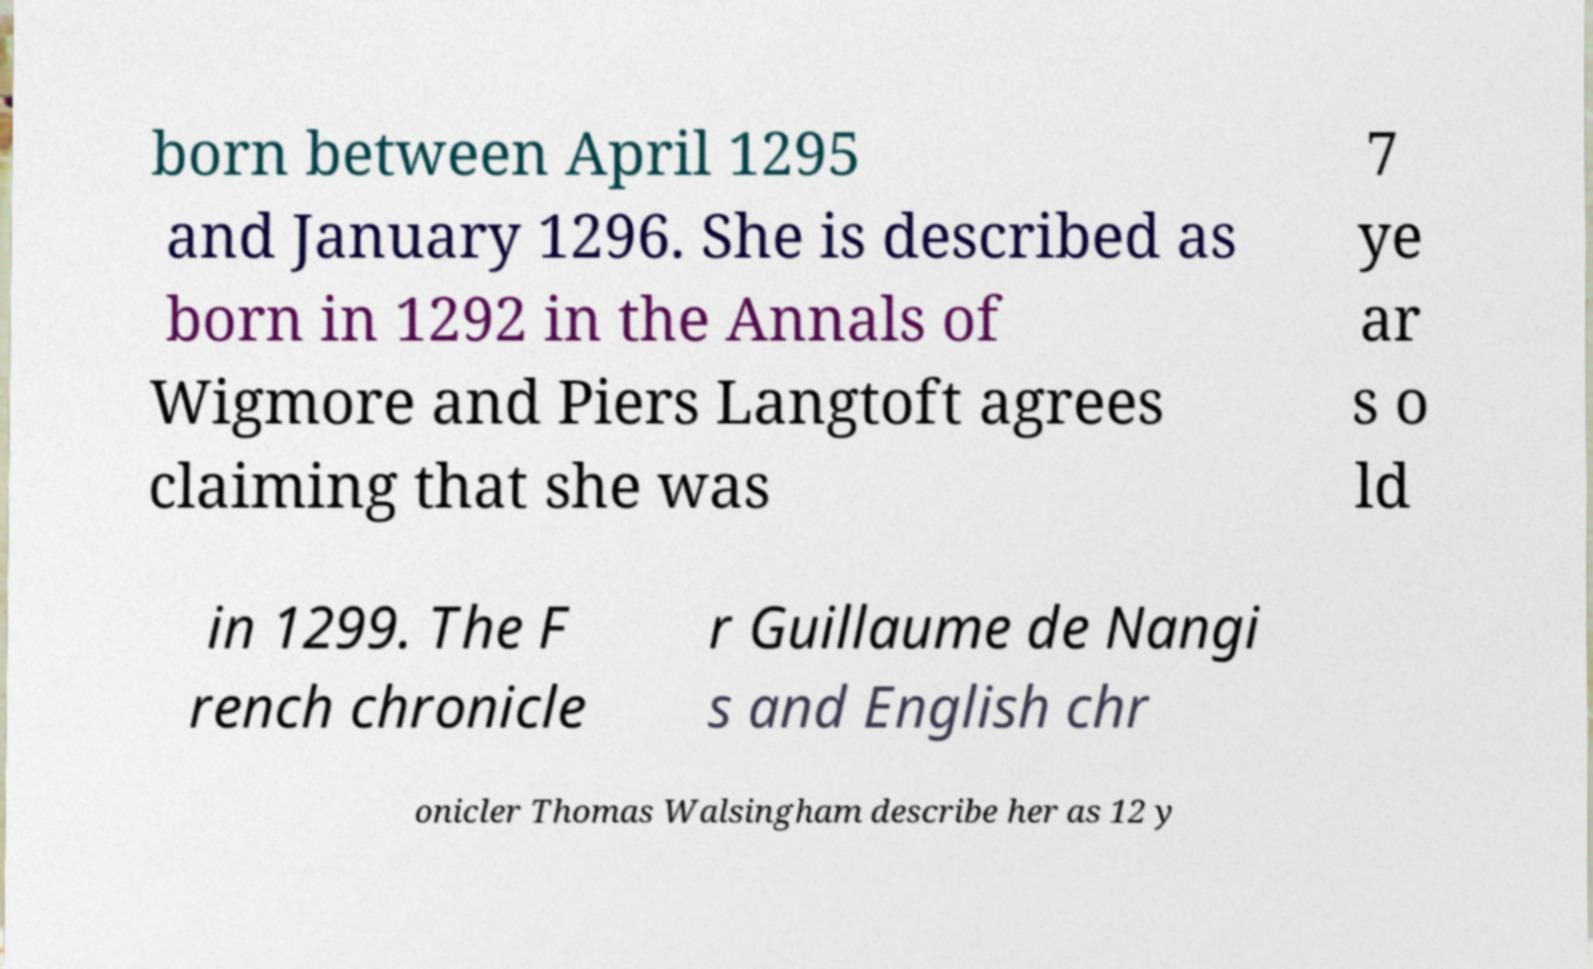Could you assist in decoding the text presented in this image and type it out clearly? born between April 1295 and January 1296. She is described as born in 1292 in the Annals of Wigmore and Piers Langtoft agrees claiming that she was 7 ye ar s o ld in 1299. The F rench chronicle r Guillaume de Nangi s and English chr onicler Thomas Walsingham describe her as 12 y 